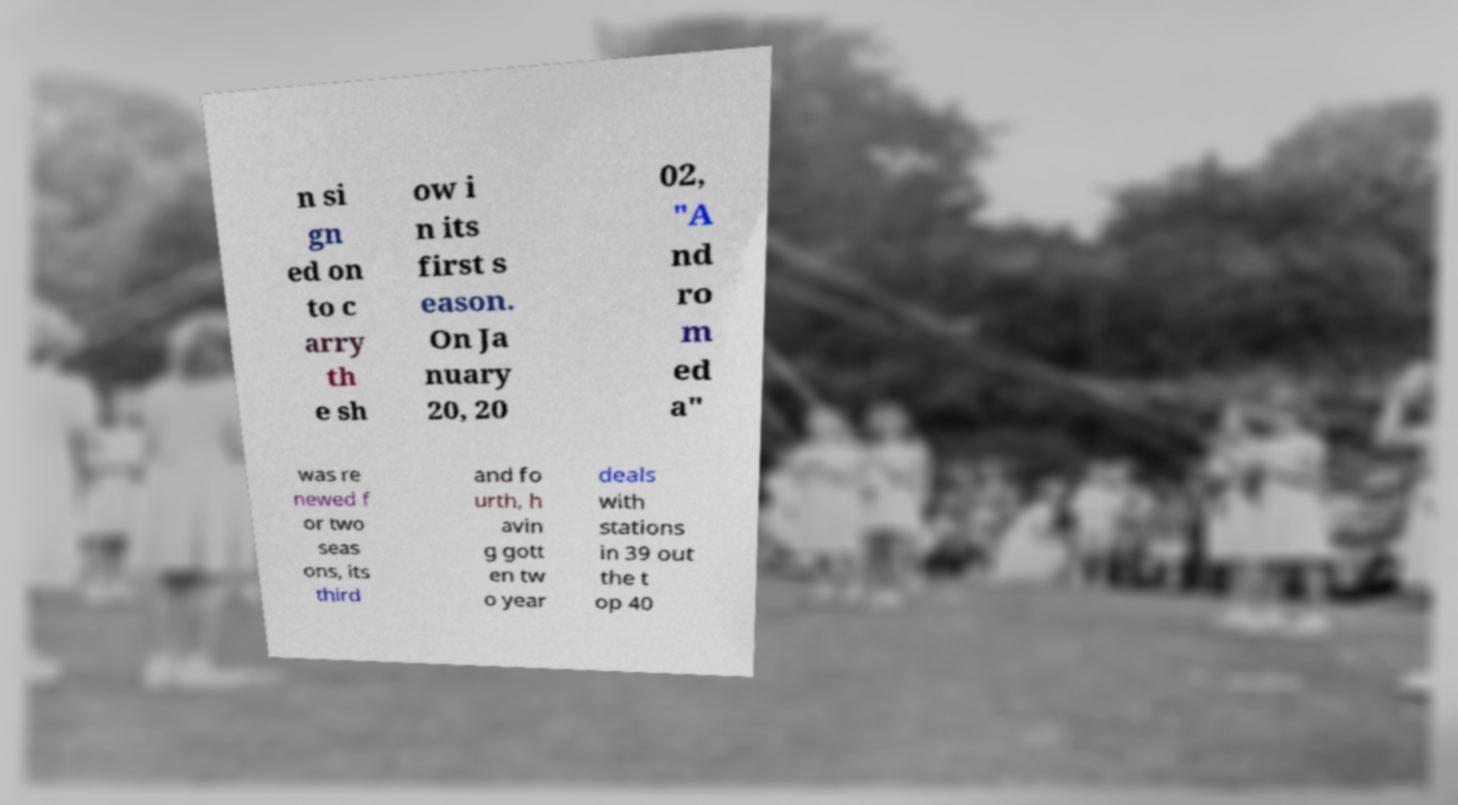Could you assist in decoding the text presented in this image and type it out clearly? n si gn ed on to c arry th e sh ow i n its first s eason. On Ja nuary 20, 20 02, "A nd ro m ed a" was re newed f or two seas ons, its third and fo urth, h avin g gott en tw o year deals with stations in 39 out the t op 40 